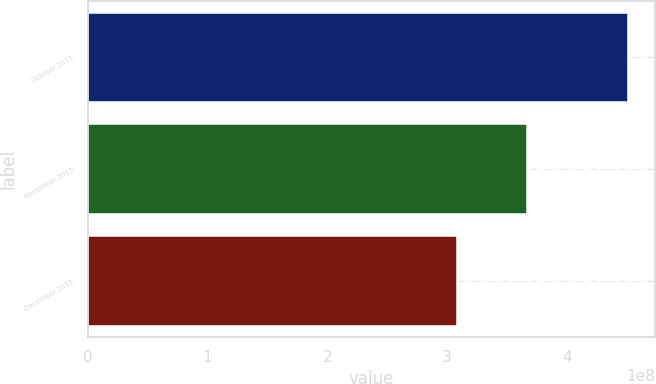Convert chart to OTSL. <chart><loc_0><loc_0><loc_500><loc_500><bar_chart><fcel>October 2015<fcel>November 2015<fcel>December 2015<nl><fcel>4.51555e+08<fcel>3.66982e+08<fcel>3.08193e+08<nl></chart> 